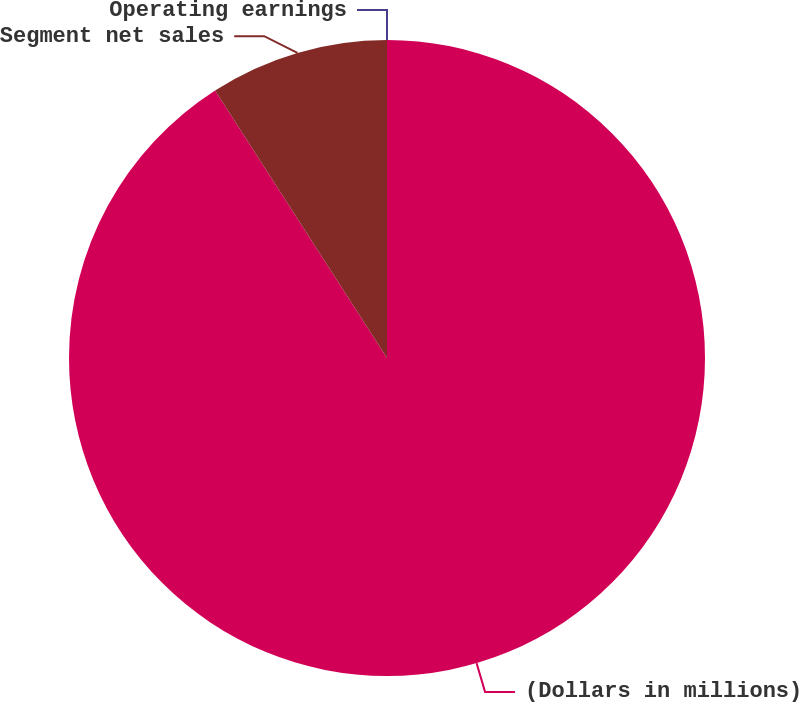Convert chart. <chart><loc_0><loc_0><loc_500><loc_500><pie_chart><fcel>(Dollars in millions)<fcel>Segment net sales<fcel>Operating earnings<nl><fcel>90.91%<fcel>9.09%<fcel>0.0%<nl></chart> 